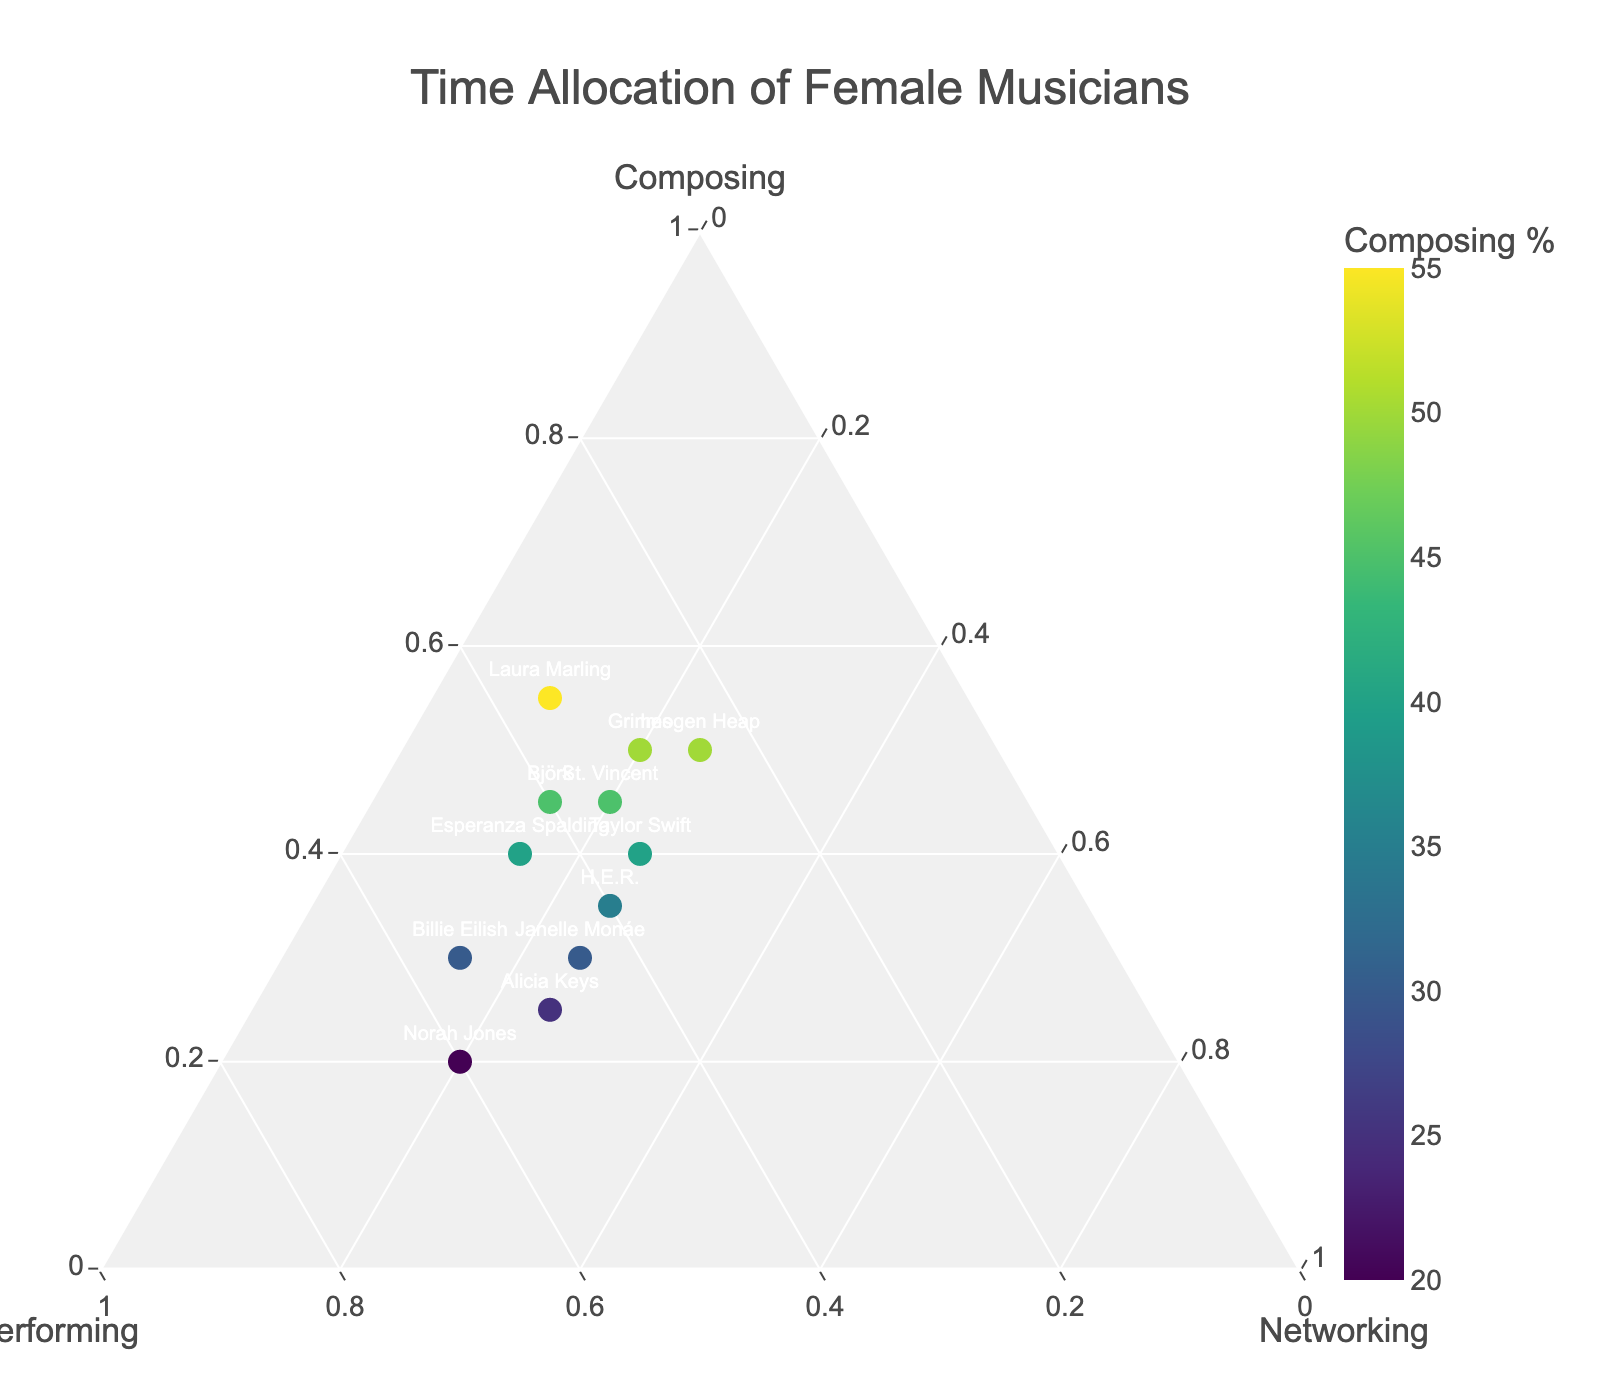How many musicians spend 50% or more of their time composing? To find the answer, count the number of musicians whose markers are at or above the 50% mark on the 'Composing' axis. Based on the plot, there are four such musicians: Grimes, Imogen Heap, Laura Marling, and St. Vincent.
Answer: 4 Which musician spends the highest percentage of time composing? To find the musician with the largest value on the 'Composing' axis, look for the marker furthest along that axis. Laura Marling spends 55% of her time composing, which is the highest.
Answer: Laura Marling Do any musicians spend equal time on performing and networking? Look for musicians where the values on the 'Performing' and 'Networking' axes are the same. Based on the plot, none of the musicians have equal percentages in performing and networking.
Answer: No Who allocates the most time to performing compared to composing and networking? Identify the musician whose marker is positioned furthest towards the 'Performing' axis. Norah Jones spends 60% of her time performing, which is the highest compared to composing and networking.
Answer: Norah Jones What's the total percentage of time composing and performing for Billie Eilish? Add the percentages Billie Eilish spends composing and performing: 30% + 55% = 85%. Therefore, Billie Eilish spends a total of 85% of her time composing and performing.
Answer: 85% Which musicians spend more time on networking than composing? To find the relevant musicians, check for those whose 'Networking' value is greater than their 'Composing' value. There are no musicians who spend more time on networking than composing in this dataset.
Answer: None Which two musicians have the closest allocation in composing and performing? Find the differences between composing and performing percentages for each musician and identify the smallest difference. Billie Eilish (25), Taylor Swift (5), H.E.R. (5), Alicia Keys (25), St. Vincent (10), Grimes (20), Norah Jones (40), Janelle Monáe (15), Laura Marling (20), Esperanza Spalding (5), Björk (5), Imogen Heap (25). H.E.R., Taylor Swift, and Esperanza Spalding have equal smallest differences of 5.
Answer: H.E.R., Taylor Swift, Esperanza Spalding 